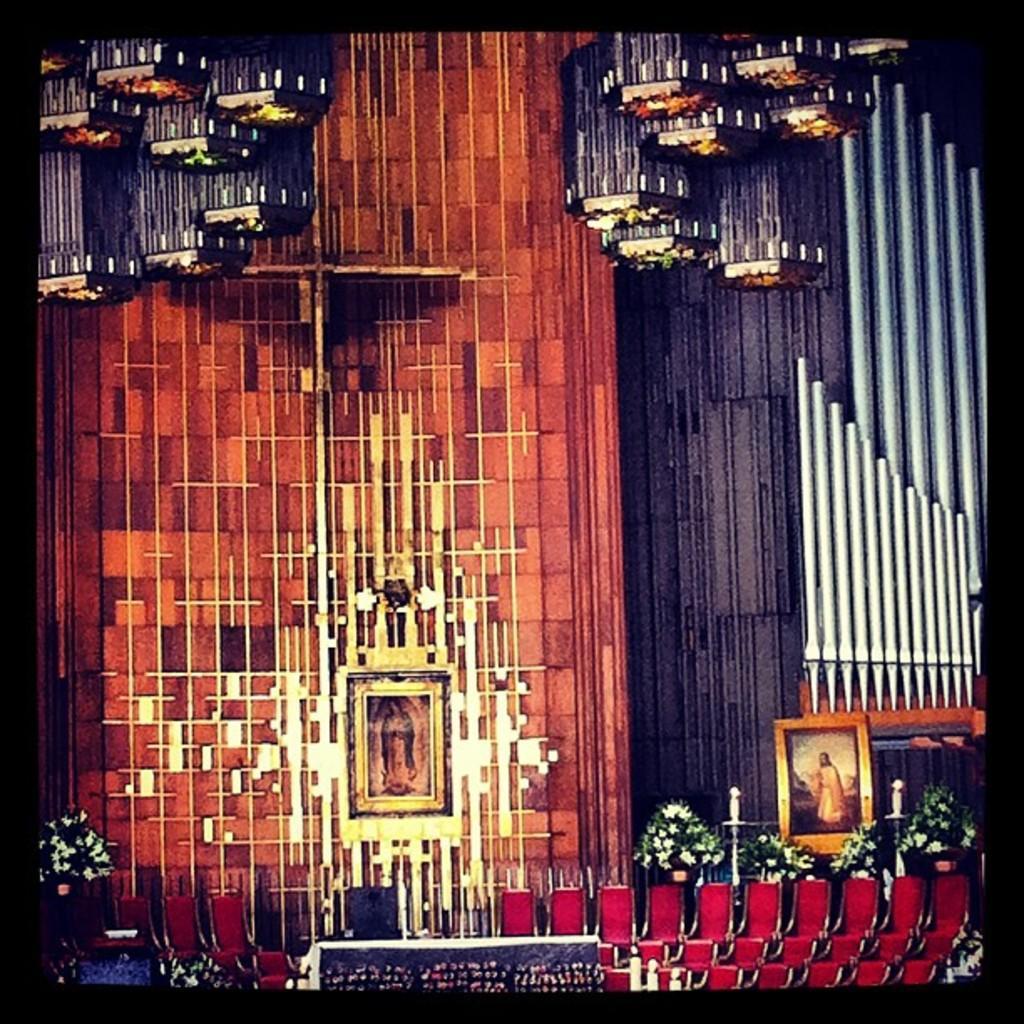Can you describe this image briefly? In this image in the middle, there are photo frames, candles, flower vases, staircase, lights, decorations and wall. 